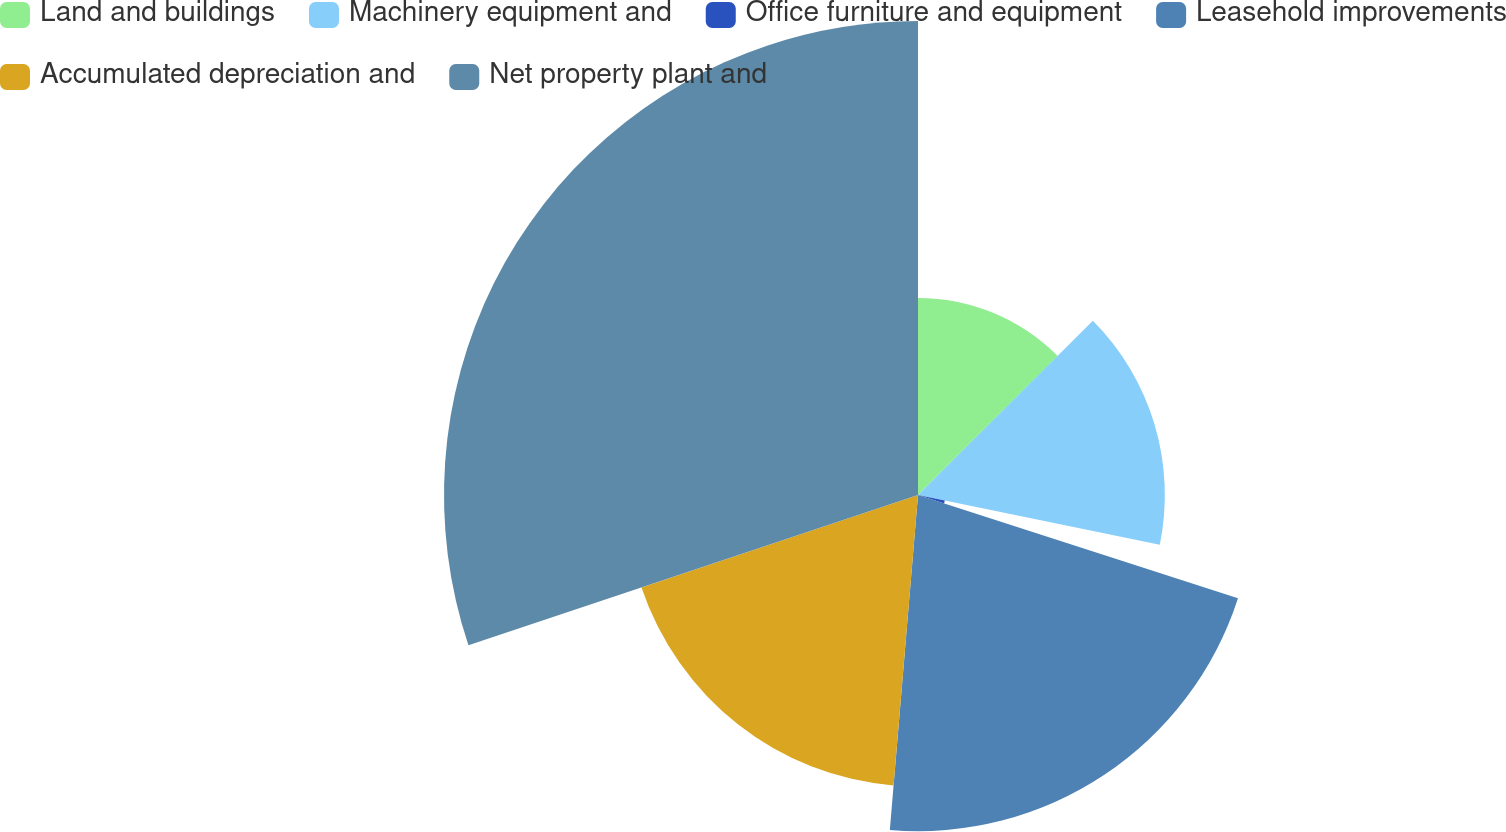Convert chart. <chart><loc_0><loc_0><loc_500><loc_500><pie_chart><fcel>Land and buildings<fcel>Machinery equipment and<fcel>Office furniture and equipment<fcel>Leasehold improvements<fcel>Accumulated depreciation and<fcel>Net property plant and<nl><fcel>12.53%<fcel>15.69%<fcel>1.74%<fcel>21.37%<fcel>18.53%<fcel>30.13%<nl></chart> 